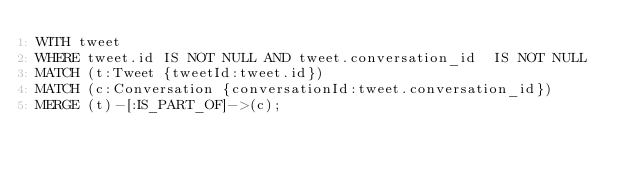Convert code to text. <code><loc_0><loc_0><loc_500><loc_500><_SQL_>WITH tweet
WHERE tweet.id IS NOT NULL AND tweet.conversation_id  IS NOT NULL
MATCH (t:Tweet {tweetId:tweet.id})
MATCH (c:Conversation {conversationId:tweet.conversation_id})
MERGE (t)-[:IS_PART_OF]->(c);
</code> 